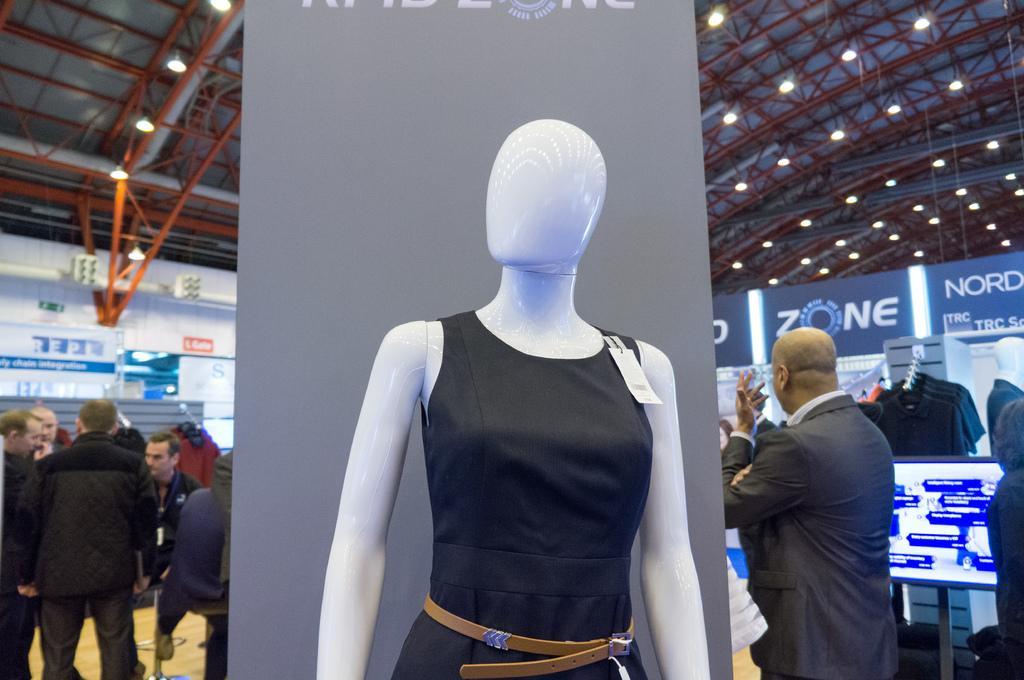Describe this image in one or two sentences. In this image I can see a white colour mannequin wearing black dress and brown colour belt. In the background I can see number of people are standing. I can also see few boards, a screen, one more mannequin and number of clothes. On these words I can see something is written. 